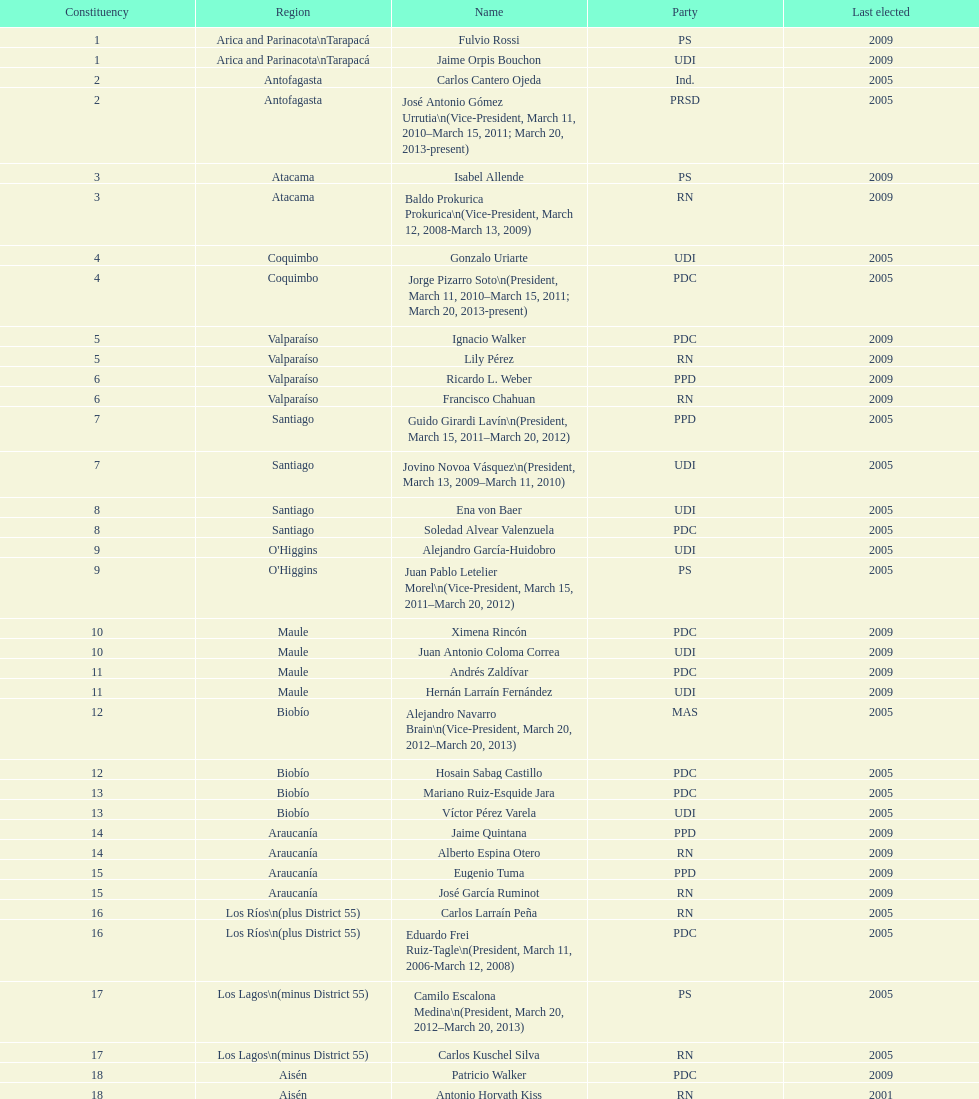Could you help me parse every detail presented in this table? {'header': ['Constituency', 'Region', 'Name', 'Party', 'Last elected'], 'rows': [['1', 'Arica and Parinacota\\nTarapacá', 'Fulvio Rossi', 'PS', '2009'], ['1', 'Arica and Parinacota\\nTarapacá', 'Jaime Orpis Bouchon', 'UDI', '2009'], ['2', 'Antofagasta', 'Carlos Cantero Ojeda', 'Ind.', '2005'], ['2', 'Antofagasta', 'José Antonio Gómez Urrutia\\n(Vice-President, March 11, 2010–March 15, 2011; March 20, 2013-present)', 'PRSD', '2005'], ['3', 'Atacama', 'Isabel Allende', 'PS', '2009'], ['3', 'Atacama', 'Baldo Prokurica Prokurica\\n(Vice-President, March 12, 2008-March 13, 2009)', 'RN', '2009'], ['4', 'Coquimbo', 'Gonzalo Uriarte', 'UDI', '2005'], ['4', 'Coquimbo', 'Jorge Pizarro Soto\\n(President, March 11, 2010–March 15, 2011; March 20, 2013-present)', 'PDC', '2005'], ['5', 'Valparaíso', 'Ignacio Walker', 'PDC', '2009'], ['5', 'Valparaíso', 'Lily Pérez', 'RN', '2009'], ['6', 'Valparaíso', 'Ricardo L. Weber', 'PPD', '2009'], ['6', 'Valparaíso', 'Francisco Chahuan', 'RN', '2009'], ['7', 'Santiago', 'Guido Girardi Lavín\\n(President, March 15, 2011–March 20, 2012)', 'PPD', '2005'], ['7', 'Santiago', 'Jovino Novoa Vásquez\\n(President, March 13, 2009–March 11, 2010)', 'UDI', '2005'], ['8', 'Santiago', 'Ena von Baer', 'UDI', '2005'], ['8', 'Santiago', 'Soledad Alvear Valenzuela', 'PDC', '2005'], ['9', "O'Higgins", 'Alejandro García-Huidobro', 'UDI', '2005'], ['9', "O'Higgins", 'Juan Pablo Letelier Morel\\n(Vice-President, March 15, 2011–March 20, 2012)', 'PS', '2005'], ['10', 'Maule', 'Ximena Rincón', 'PDC', '2009'], ['10', 'Maule', 'Juan Antonio Coloma Correa', 'UDI', '2009'], ['11', 'Maule', 'Andrés Zaldívar', 'PDC', '2009'], ['11', 'Maule', 'Hernán Larraín Fernández', 'UDI', '2009'], ['12', 'Biobío', 'Alejandro Navarro Brain\\n(Vice-President, March 20, 2012–March 20, 2013)', 'MAS', '2005'], ['12', 'Biobío', 'Hosain Sabag Castillo', 'PDC', '2005'], ['13', 'Biobío', 'Mariano Ruiz-Esquide Jara', 'PDC', '2005'], ['13', 'Biobío', 'Víctor Pérez Varela', 'UDI', '2005'], ['14', 'Araucanía', 'Jaime Quintana', 'PPD', '2009'], ['14', 'Araucanía', 'Alberto Espina Otero', 'RN', '2009'], ['15', 'Araucanía', 'Eugenio Tuma', 'PPD', '2009'], ['15', 'Araucanía', 'José García Ruminot', 'RN', '2009'], ['16', 'Los Ríos\\n(plus District 55)', 'Carlos Larraín Peña', 'RN', '2005'], ['16', 'Los Ríos\\n(plus District 55)', 'Eduardo Frei Ruiz-Tagle\\n(President, March 11, 2006-March 12, 2008)', 'PDC', '2005'], ['17', 'Los Lagos\\n(minus District 55)', 'Camilo Escalona Medina\\n(President, March 20, 2012–March 20, 2013)', 'PS', '2005'], ['17', 'Los Lagos\\n(minus District 55)', 'Carlos Kuschel Silva', 'RN', '2005'], ['18', 'Aisén', 'Patricio Walker', 'PDC', '2009'], ['18', 'Aisén', 'Antonio Horvath Kiss', 'RN', '2001'], ['19', 'Magallanes', 'Carlos Bianchi Chelech\\n(Vice-President, March 13, 2009–March 11, 2010)', 'Ind.', '2005'], ['19', 'Magallanes', 'Pedro Muñoz Aburto', 'PS', '2005']]} What is the last region listed on the table? Magallanes. 